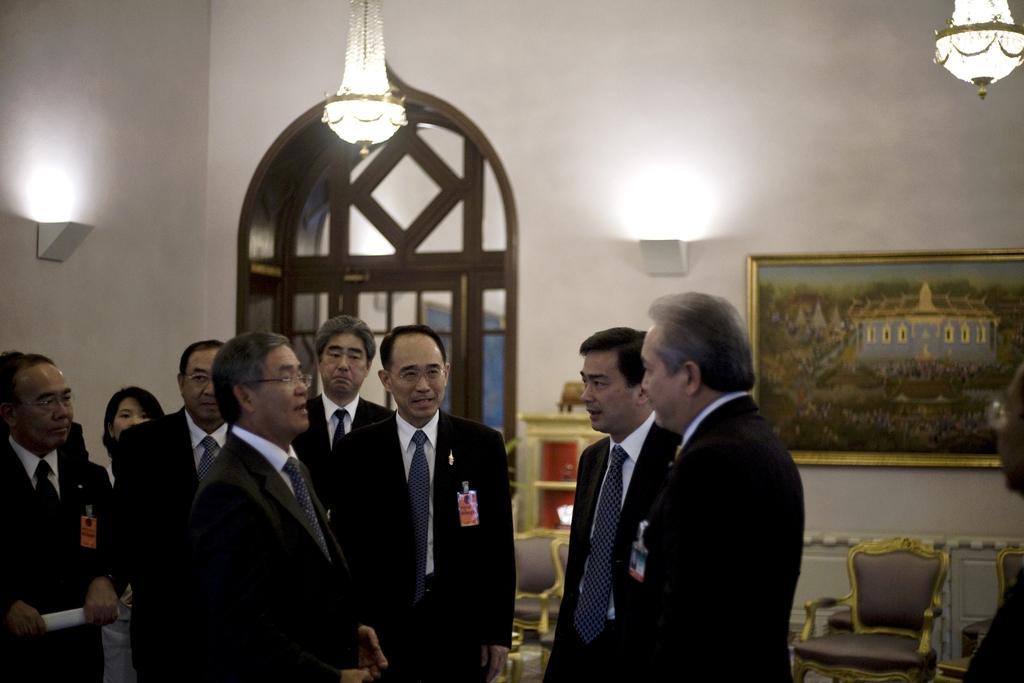How would you summarize this image in a sentence or two? In this image we can see many people are standing. And we can see some of them wearing spectacles. And we can see they are wearing identity cards. And we can see the chairs. And we can see the hanging lamps. And we can see the lights. And we can see one painting on the wall. And we can see cupboard. And we can see one object on the cupboard. And we can see the door. And we can see one woman behind them. 